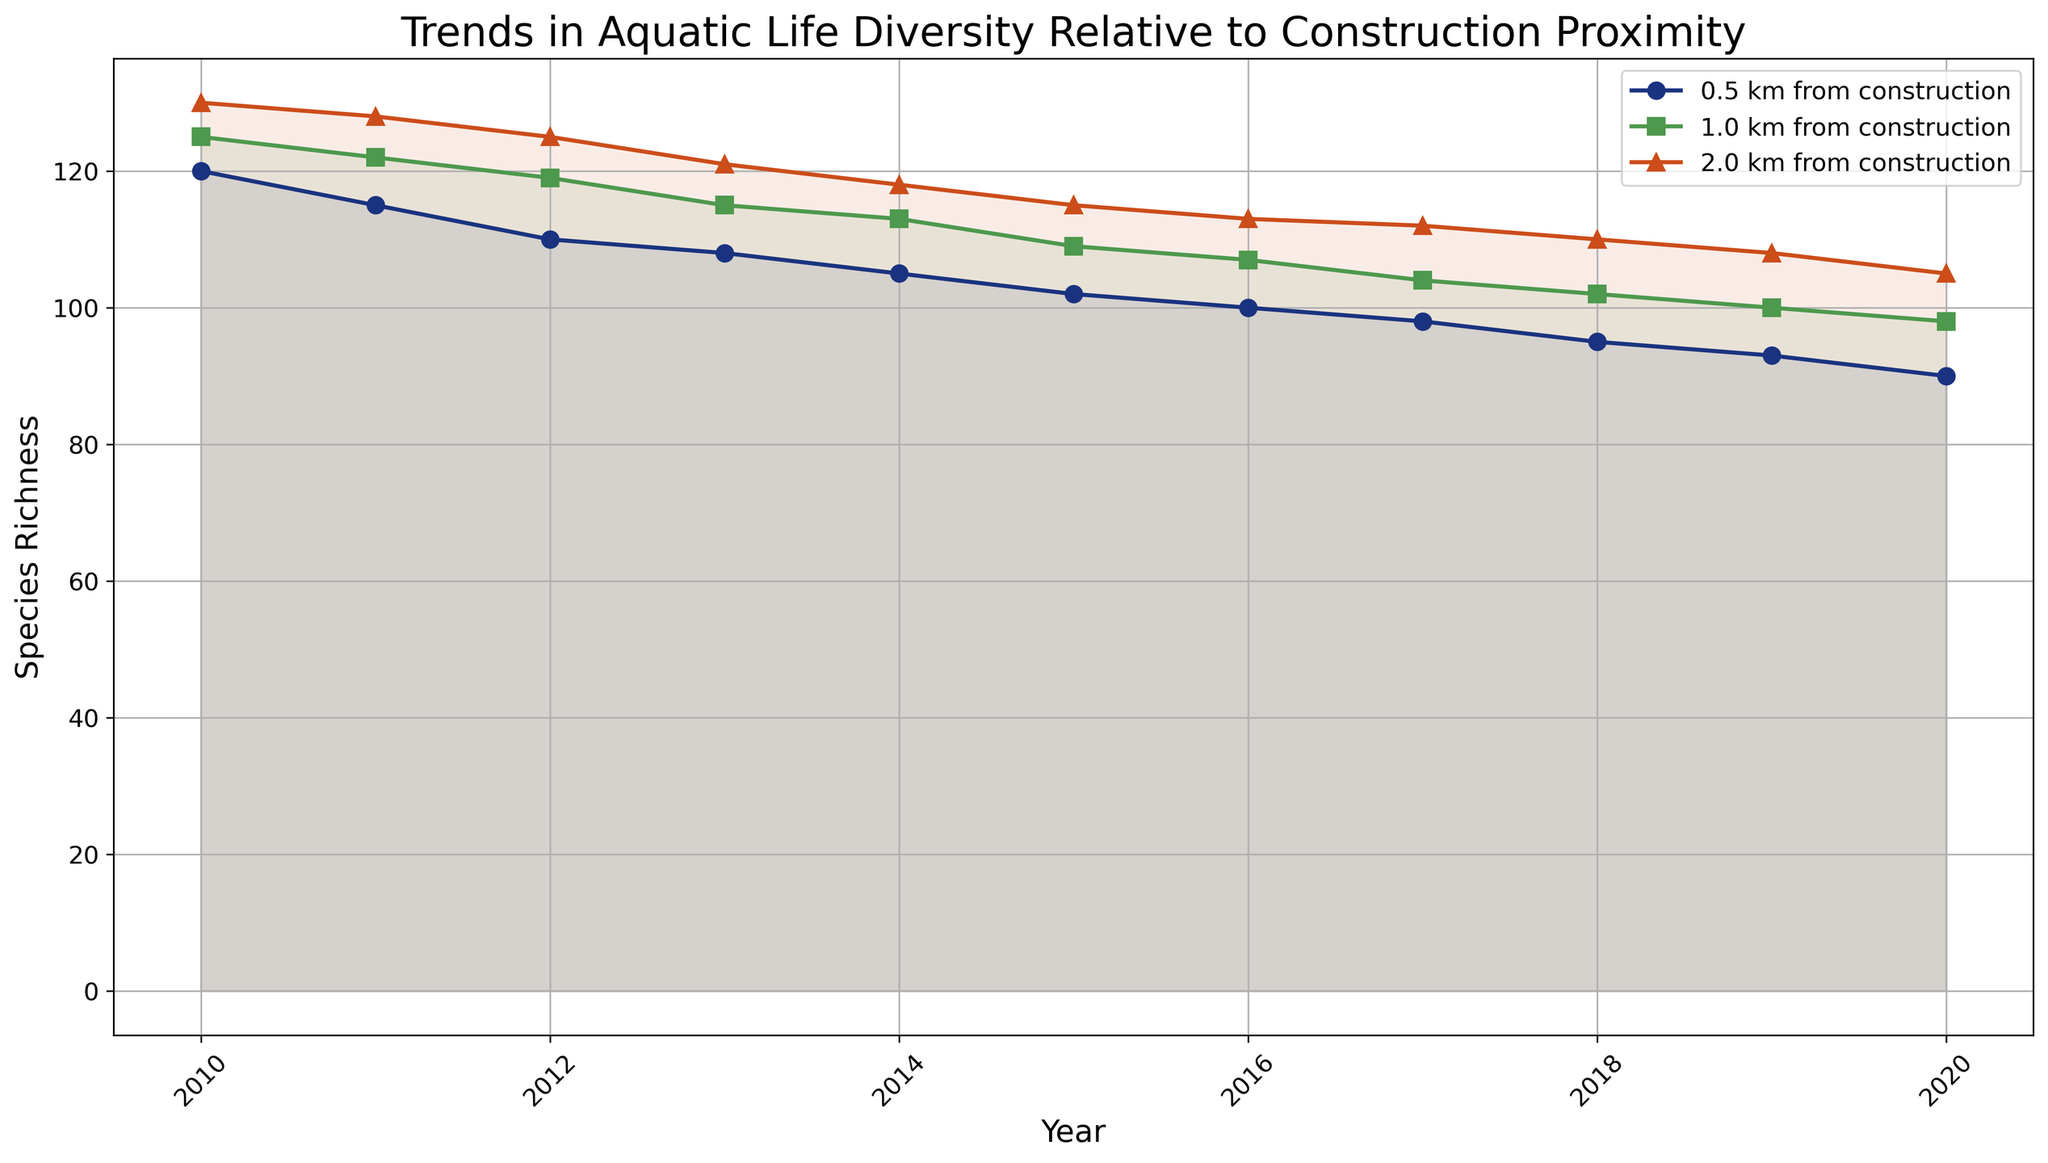What is the general trend in species richness over the years for locations 0.5 km from construction? The species richness for locations 0.5 km from construction shows a consistent decline from 2010 to 2020. Starting at a species richness of 120 in 2010 and dropping to 90 in 2020. This downward trend indicates that as the years progress, the aquatic life diversity near the construction site decreases.
Answer: Downward trend Which distance from construction site saw the least change in species richness from 2010 to 2020? We first identify the species richness for each distance in 2010 and 2020. For 0.5 km, it goes from 120 to 90; for 1.0 km, it goes from 125 to 98; for 2.0 km, it goes from 130 to 105. The least change is observed in the 2.0 km distance range since the change here is only 25 (from 130 to 105).
Answer: 2.0 km How does the species richness at 1.0 km from construction in 2015 compare to that at 0.5 km from construction in 2020? In 2015, the species richness at 1.0 km from construction was 109. In 2020, the species richness at 0.5 km from construction was 90. To compare, 109 is higher than 90.
Answer: Higher What is the average species richness for locations 2.0 km from construction across the entire period? The species richness values for 2.0 km from 2010 to 2020 are 130, 128, 125, 121, 118, 115, 113, 112, 110, 108, 105. Summing them gives 1285. There are 11 years of data, so the average is 1285 / 11 = 116.8
Answer: 116.8 Which year had the highest species richness at any distance from the construction site? By reviewing the trends for each distance, the highest species richness observed is 130 in 2010 for 2.0 km from construction. No other year or distance surpasses this value.
Answer: 2010 Is the decline in species richness more pronounced closer to the construction site as compared to farther away? Comparing the changes from 2010 to 2020, for 0.5 km the decline is from 120 to 90 (30 units), for 1.0 km it declines from 125 to 98 (27 units), and for 2.0 km from 130 to 105 (25 units). The largest decline (30 units) is at 0.5 km, indicating the decline is more pronounced closer to the construction site.
Answer: Yes What is the median species richness for the 1.0 km distance over the years? Median is the middle value in an ordered list. The species richness values for 1.0 km are 125, 122, 119, 115, 113, 109, 107, 104, 102, 100, 98. Ordering them, the middle value (6th) is 109.
Answer: 109 